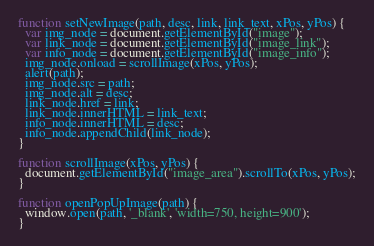<code> <loc_0><loc_0><loc_500><loc_500><_JavaScript_>function setNewImage(path, desc, link, link_text, xPos, yPos) {
  var img_node = document.getElementById("image");
  var link_node = document.getElementById("image_link");
  var info_node = document.getElementById("image_info");
  img_node.onload = scrollImage(xPos, yPos);
  alert(path);
  img_node.src = path;
  img_node.alt = desc;
  link_node.href = link;
  link_node.innerHTML = link_text;
  info_node.innerHTML = desc;
  info_node.appendChild(link_node);
}

function scrollImage(xPos, yPos) {
  document.getElementById("image_area").scrollTo(xPos, yPos);
}

function openPopUpImage(path) {
  window.open(path, '_blank', 'width=750, height=900');
}
</code> 